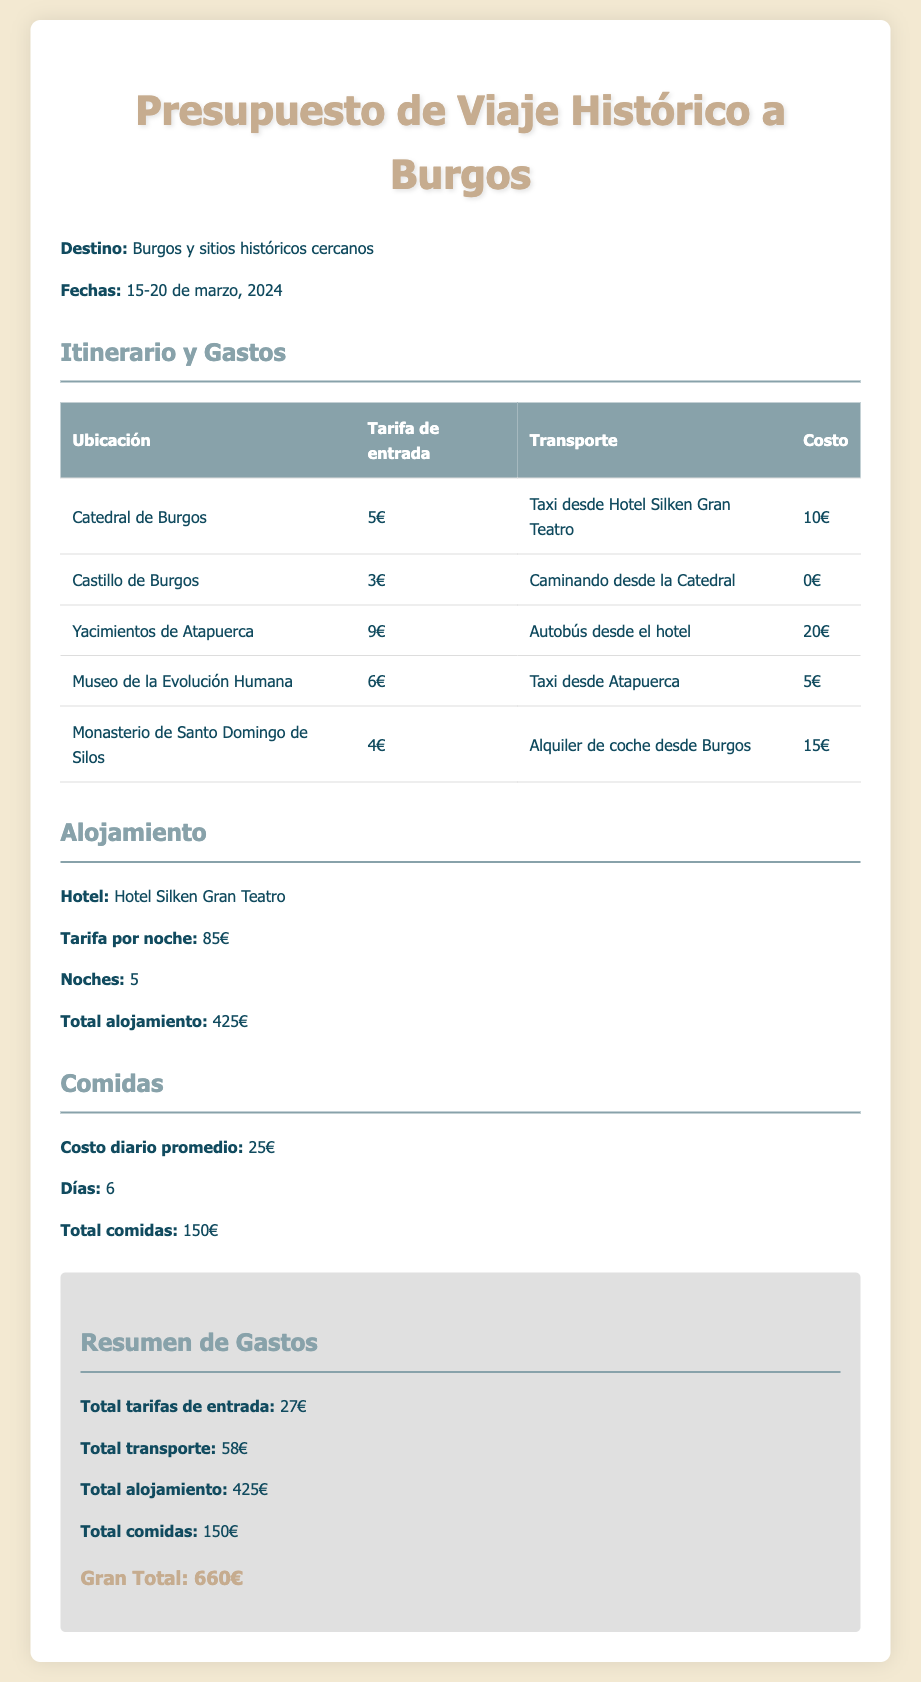what is the destination of the trip? The destination is clearly stated in the document as Burgos and nearby historical sites.
Answer: Burgos y sitios históricos cercanos what are the travel dates? The document specifies the travel dates as March 15 to March 20, 2024.
Answer: 15-20 de marzo, 2024 what is the total cost of meals? The total cost of meals is calculated for 6 days at an average daily cost of 25 euros, resulting in 150 euros.
Answer: 150€ how much is the accommodation per night? The document lists the accommodation cost per night at 85 euros.
Answer: 85€ what is the total entry fee for all sites? The total entry fee is the sum of all the individual fees listed in the document, adding up to 27 euros.
Answer: 27€ how many nights will the accommodation be booked? The document indicates that the accommodation will be booked for 5 nights.
Answer: 5 what is the total transportation cost? The document provides the total transportation cost as 58 euros, calculated from different transport methods listed.
Answer: 58€ which hotel will be used for accommodation? The document specifies the hotel name as Hotel Silken Gran Teatro.
Answer: Hotel Silken Gran Teatro what is the total budget for the trip? The grand total for the trip is summarized at the end of the document as 660 euros.
Answer: 660€ 